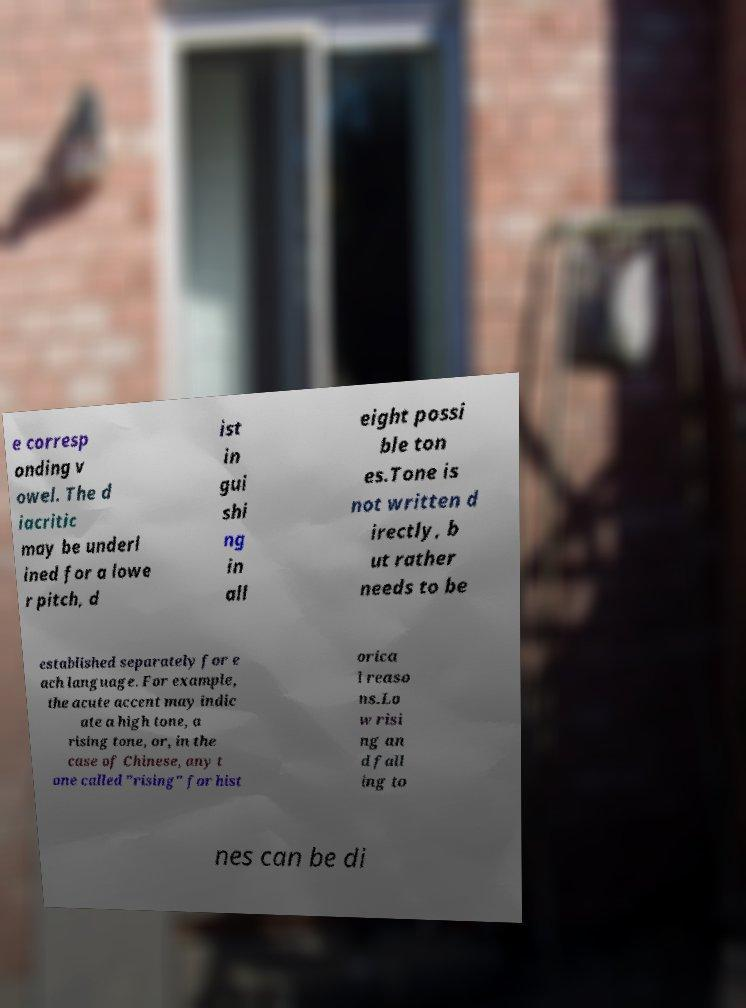I need the written content from this picture converted into text. Can you do that? e corresp onding v owel. The d iacritic may be underl ined for a lowe r pitch, d ist in gui shi ng in all eight possi ble ton es.Tone is not written d irectly, b ut rather needs to be established separately for e ach language. For example, the acute accent may indic ate a high tone, a rising tone, or, in the case of Chinese, any t one called "rising" for hist orica l reaso ns.Lo w risi ng an d fall ing to nes can be di 